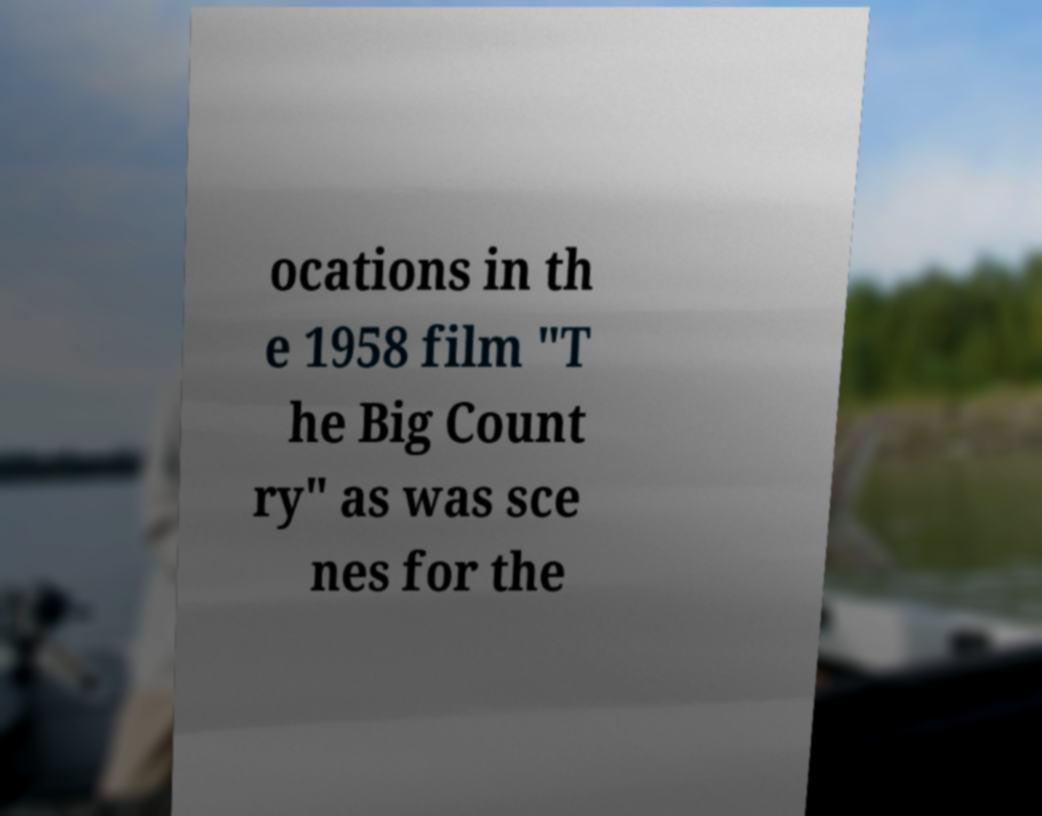Please read and relay the text visible in this image. What does it say? ocations in th e 1958 film "T he Big Count ry" as was sce nes for the 